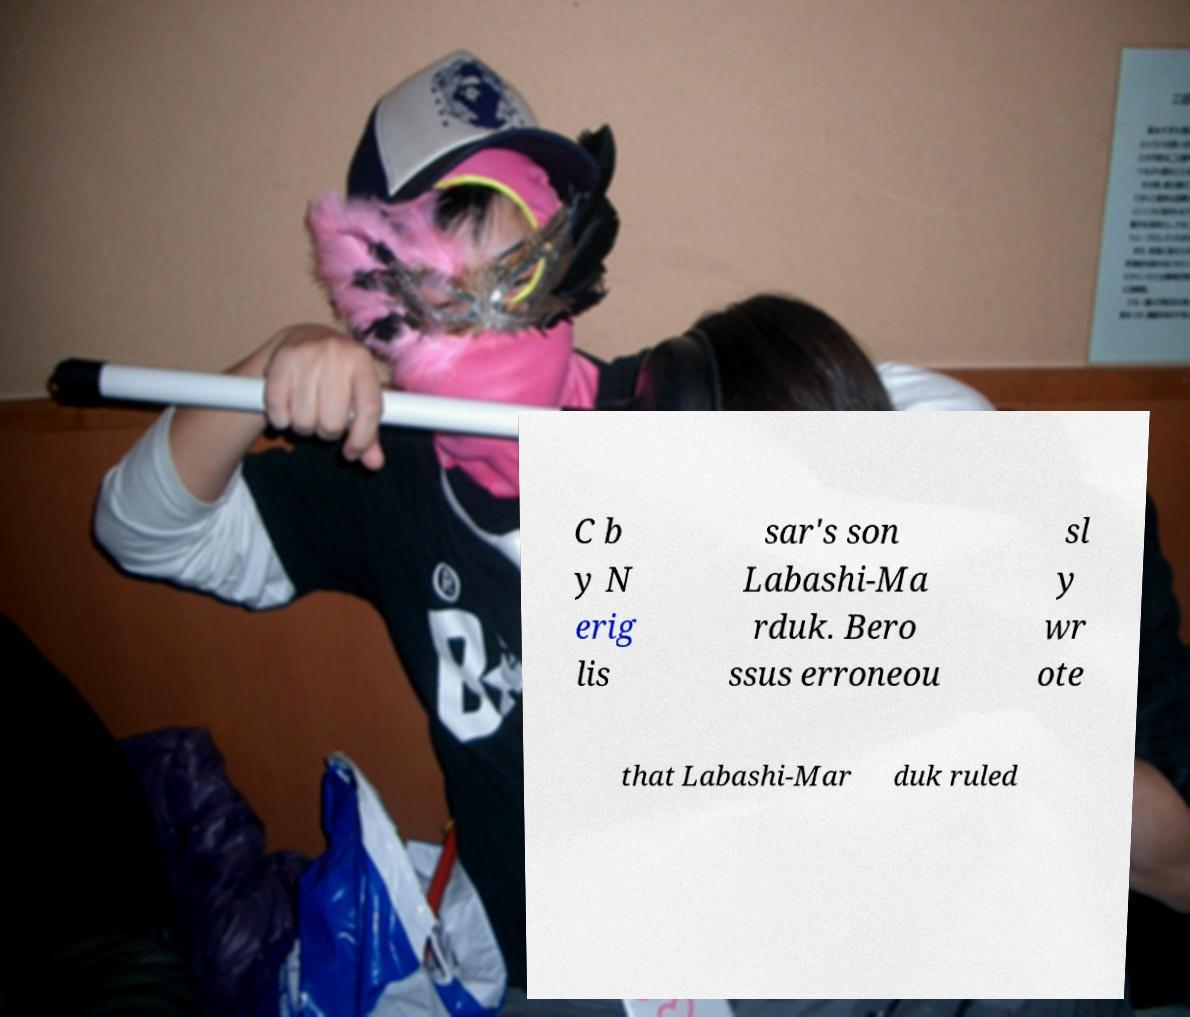Could you extract and type out the text from this image? C b y N erig lis sar's son Labashi-Ma rduk. Bero ssus erroneou sl y wr ote that Labashi-Mar duk ruled 